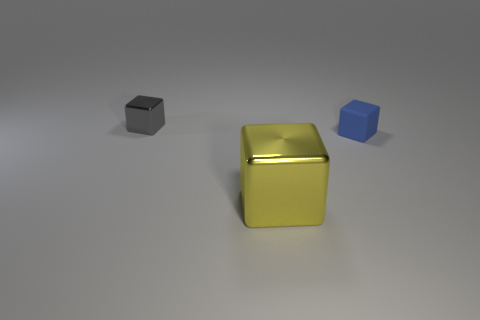There is a yellow shiny thing that is the same shape as the tiny blue matte object; what size is it?
Your answer should be very brief. Large. Is there any other thing that has the same size as the yellow cube?
Offer a terse response. No. There is another large thing that is the same shape as the blue matte thing; what color is it?
Offer a very short reply. Yellow. Is the number of small objects on the left side of the small blue matte block less than the number of cubes that are in front of the gray metal object?
Your response must be concise. Yes. What is the color of the small cube that is right of the small gray metal thing?
Provide a short and direct response. Blue. How many blue blocks are behind the shiny thing that is behind the metal cube that is on the right side of the gray object?
Ensure brevity in your answer.  0. How big is the blue matte thing?
Your answer should be very brief. Small. What is the material of the object that is the same size as the gray cube?
Make the answer very short. Rubber. What number of yellow blocks are in front of the tiny gray metal block?
Offer a terse response. 1. Does the cube behind the blue cube have the same material as the object that is right of the yellow metal thing?
Your answer should be very brief. No. 